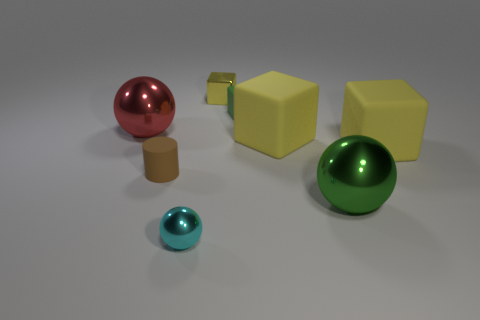How many yellow blocks must be subtracted to get 1 yellow blocks? 2 Subtract all yellow shiny cubes. How many cubes are left? 3 Subtract all green cubes. How many cubes are left? 3 Add 2 cyan blocks. How many objects exist? 10 Subtract 2 balls. How many balls are left? 1 Subtract all red spheres. Subtract all yellow cubes. How many spheres are left? 2 Subtract all purple cylinders. How many blue cubes are left? 0 Subtract all small metallic balls. Subtract all cyan metallic things. How many objects are left? 6 Add 6 tiny yellow objects. How many tiny yellow objects are left? 7 Add 1 big green metal things. How many big green metal things exist? 2 